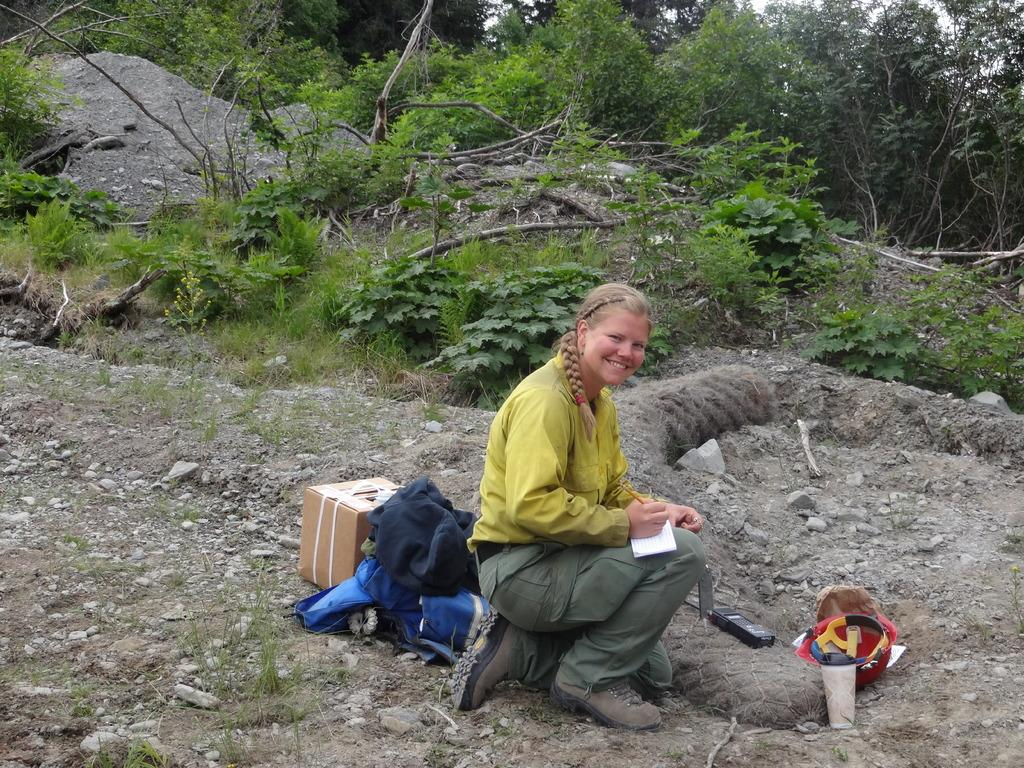What is the facial expression of the person in the image? The person in the image is smiling. What objects can be seen on the ground in the image? There is a cardboard box and a helmet on the ground, along with unspecified things. What can be seen in the background of the image? There are plants and trees in the background of the image. What type of bean is being used as a mitten in the image? There is no bean or mitten present in the image. What emotion is the person in the image expressing other than happiness? The person in the image is only shown smiling, so it is not possible to determine any other emotions they might be expressing. 